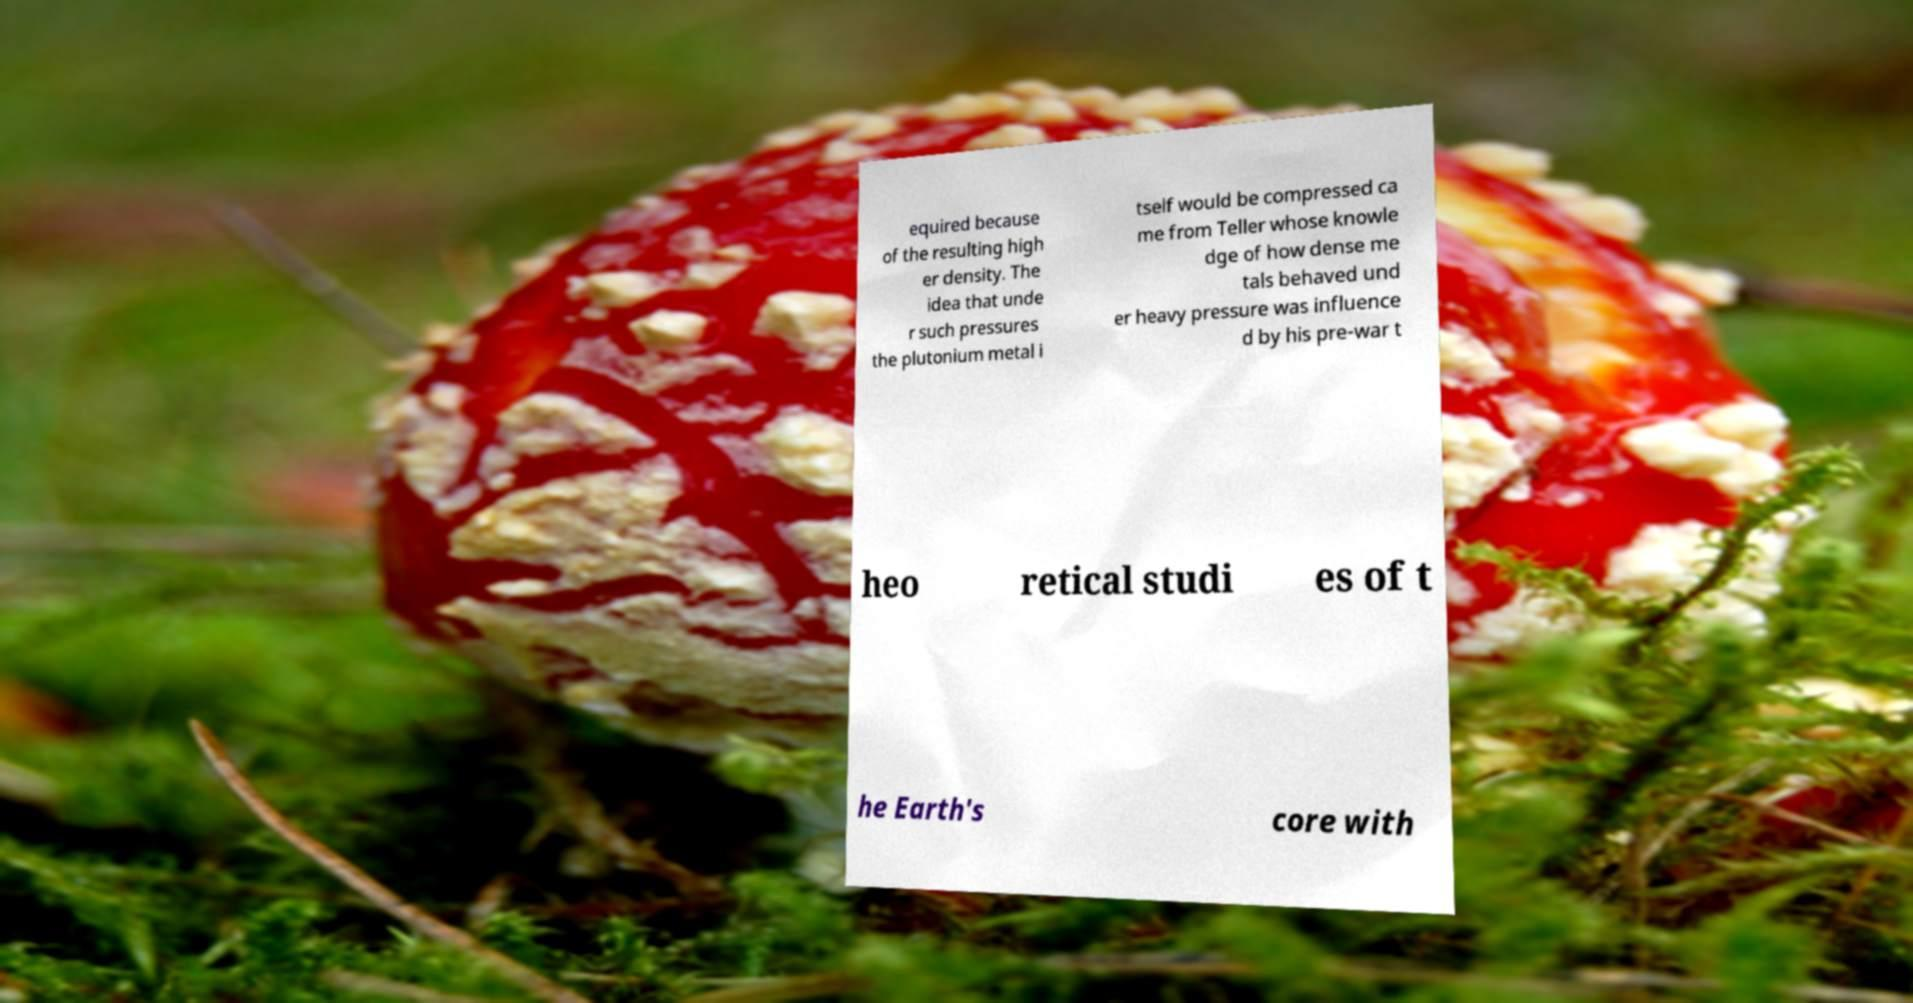Can you read and provide the text displayed in the image?This photo seems to have some interesting text. Can you extract and type it out for me? equired because of the resulting high er density. The idea that unde r such pressures the plutonium metal i tself would be compressed ca me from Teller whose knowle dge of how dense me tals behaved und er heavy pressure was influence d by his pre-war t heo retical studi es of t he Earth's core with 